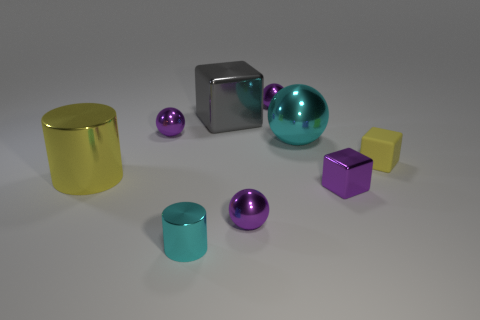What color is the tiny metallic thing to the right of the cyan sphere that is behind the shiny object that is right of the cyan sphere? The tiny metallic object to the right of the cyan sphere, which is found behind the shiny object right of said sphere, is indeed purple. 